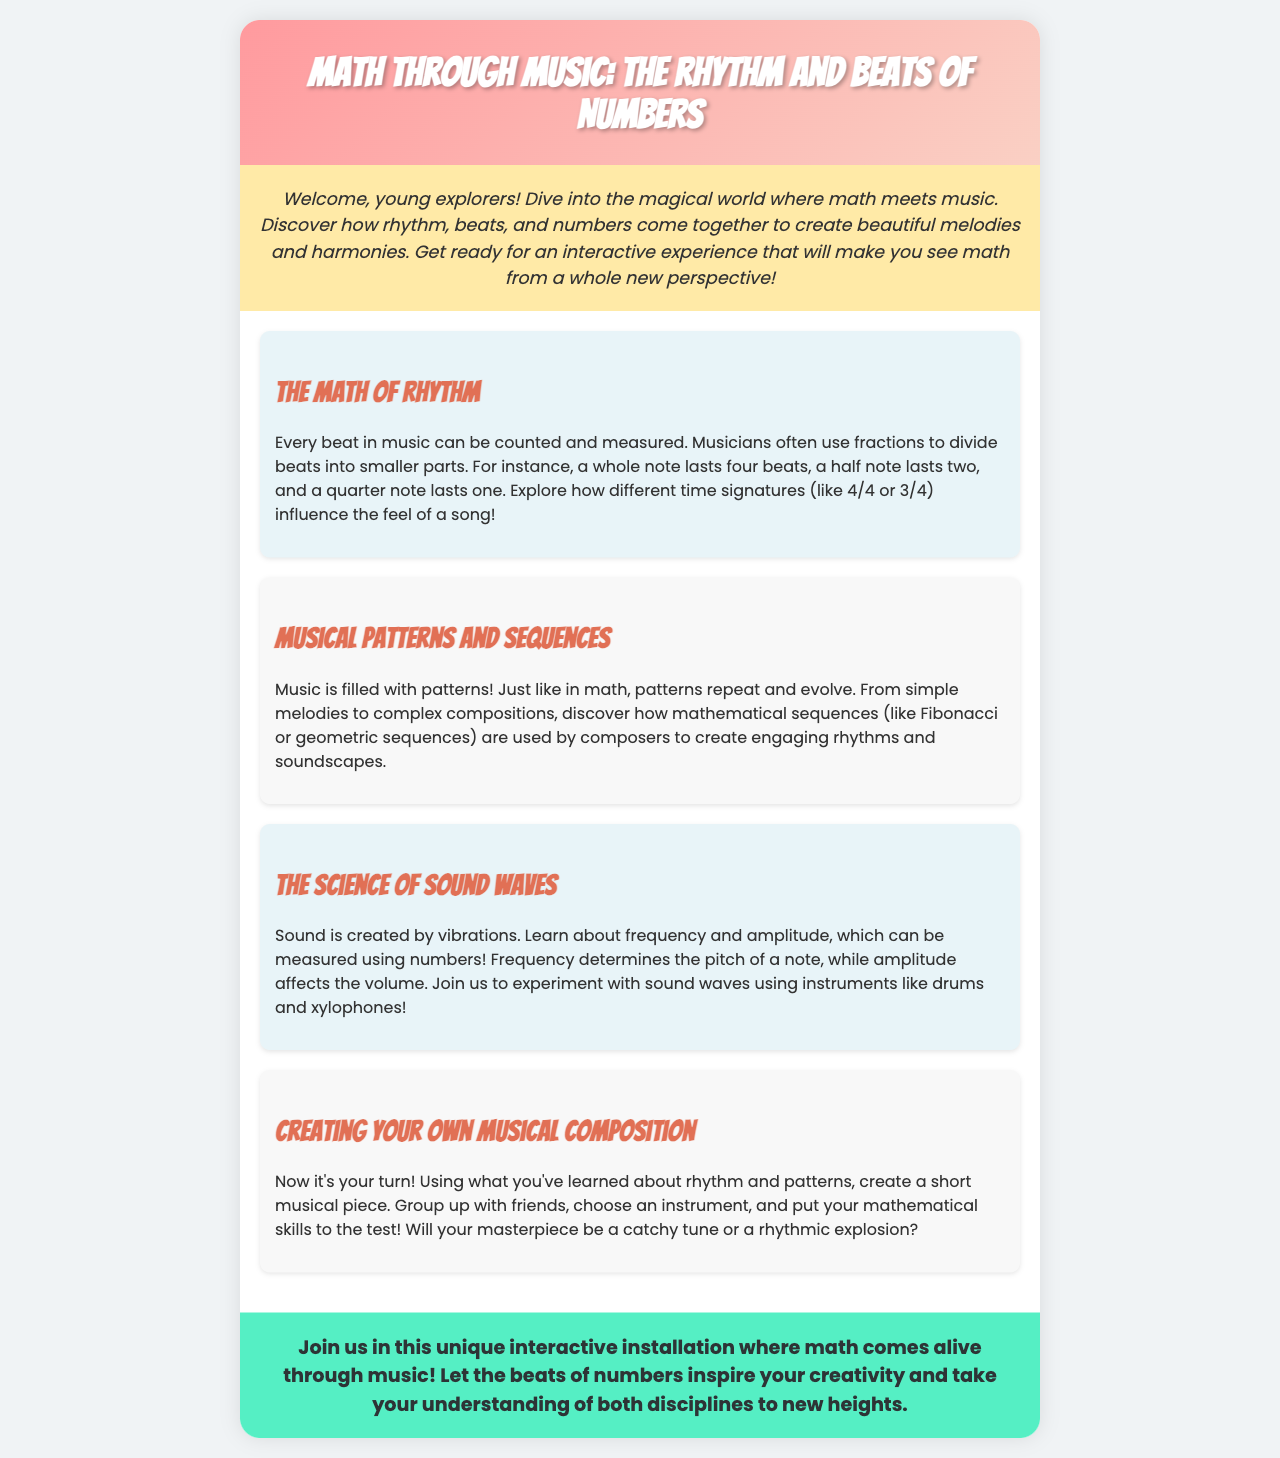What is the title of the document? The title is presented prominently at the top of the document, showcasing the main theme.
Answer: Math Through Music: The Rhythm and Beats of Numbers What can you explore in this interactive installation? The introduction highlights the key aspect of engaging with math in a creative way through music.
Answer: Math What are the two time signatures mentioned? The section on rhythm explores different time signatures used in music.
Answer: 4/4 and 3/4 What mathematical sequence is mentioned in the document? The section on musical patterns indicates a specific mathematical sequence that relates to music composition.
Answer: Fibonacci What does frequency determine in music? The section discussing sound waves specifies the relationship between frequency and an aspect of music.
Answer: Pitch How can you create your own musical piece? The document provides an activity involving collaboration and use of learned concepts.
Answer: Group up with friends What is necessary for sound to be created? The explanation of sound waves addresses the fundamental requirement for sound production.
Answer: Vibrations What is the closing statement's focus? The concluding section emphasizes the ultimate goal of the interactive experience described in the document.
Answer: Math comes alive through music 